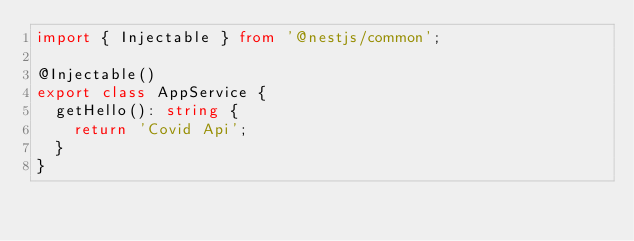<code> <loc_0><loc_0><loc_500><loc_500><_TypeScript_>import { Injectable } from '@nestjs/common';

@Injectable()
export class AppService {
  getHello(): string {
    return 'Covid Api';
  }
}
</code> 